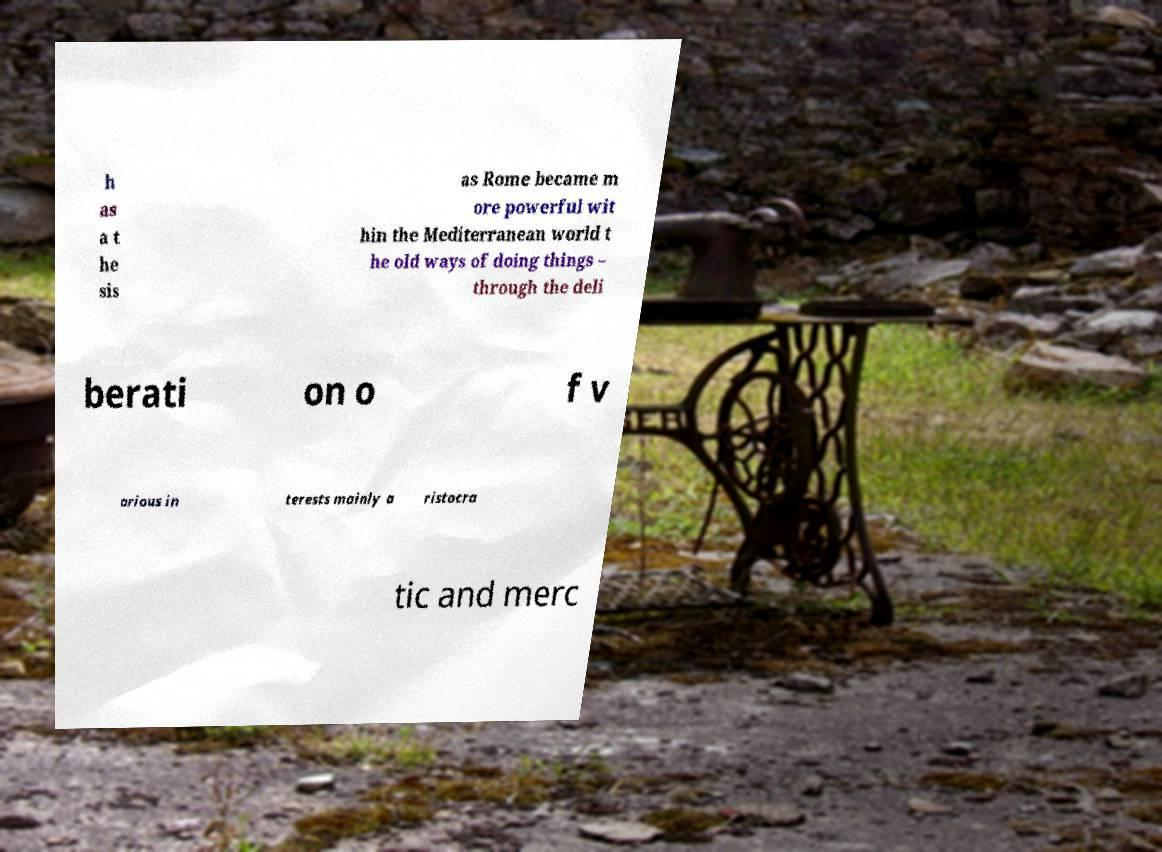Can you read and provide the text displayed in the image?This photo seems to have some interesting text. Can you extract and type it out for me? h as a t he sis as Rome became m ore powerful wit hin the Mediterranean world t he old ways of doing things – through the deli berati on o f v arious in terests mainly a ristocra tic and merc 